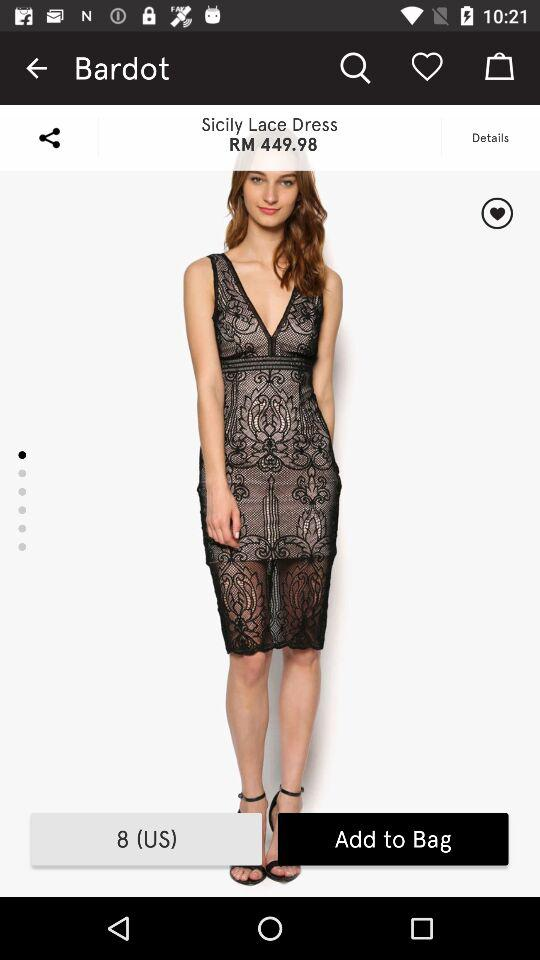What's the dress size? The dress size is 8 (US). 